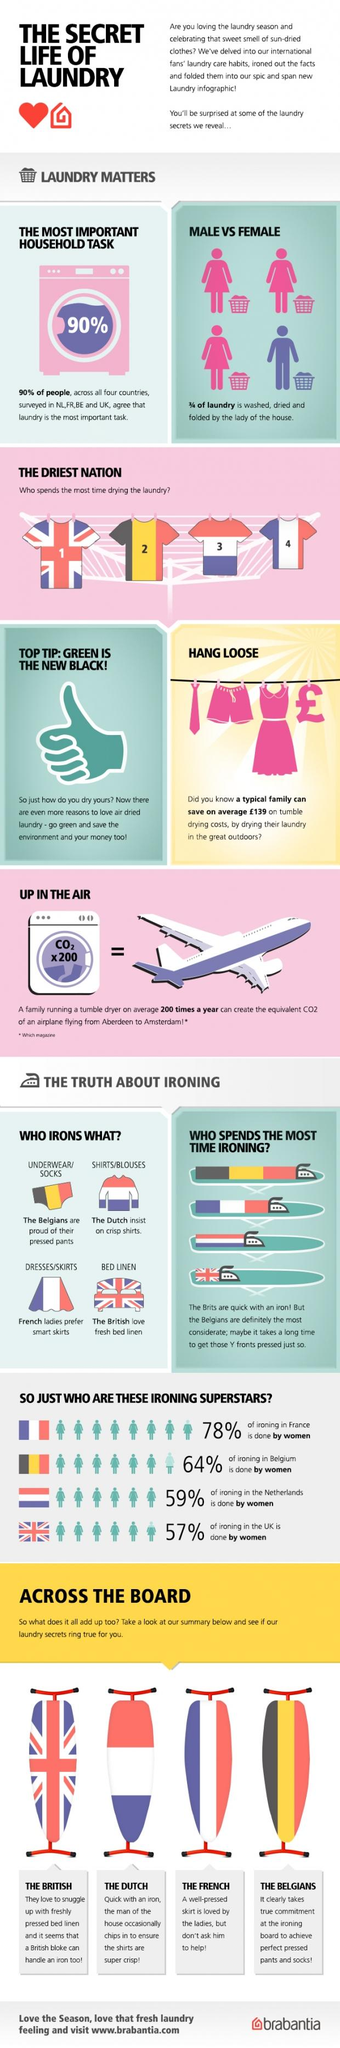Mention a couple of crucial points in this snapshot. According to a recent survey, only 22% of ironing in France is done by men. The UK has the least percentage of women doing ironing among Belgium, the Netherlands, and France. There is one male doing laundry in a group of four people. The driest country is the United Kingdom. The French love to wear neatly ironed skirts, as do Belgians, Dutch, and Britons. 